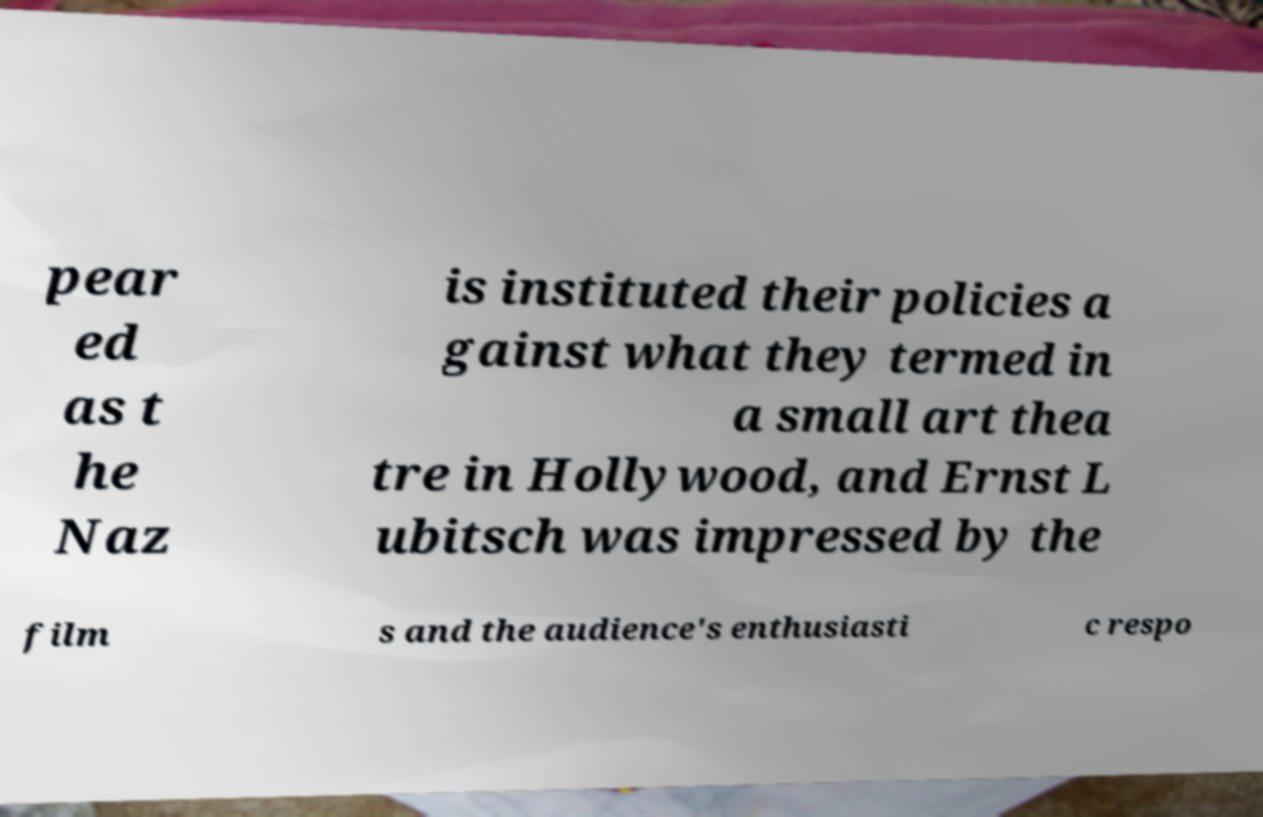Could you assist in decoding the text presented in this image and type it out clearly? pear ed as t he Naz is instituted their policies a gainst what they termed in a small art thea tre in Hollywood, and Ernst L ubitsch was impressed by the film s and the audience's enthusiasti c respo 